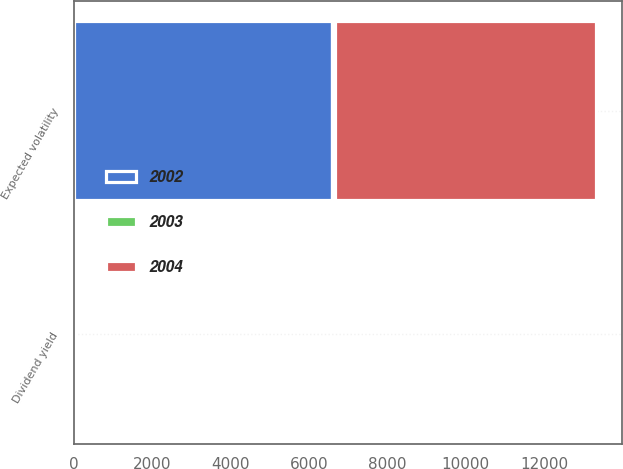Convert chart. <chart><loc_0><loc_0><loc_500><loc_500><stacked_bar_chart><ecel><fcel>Dividend yield<fcel>Expected volatility<nl><fcel>2003<fcel>0<fcel>69<nl><fcel>2004<fcel>0<fcel>6670<nl><fcel>2002<fcel>0<fcel>6589<nl></chart> 